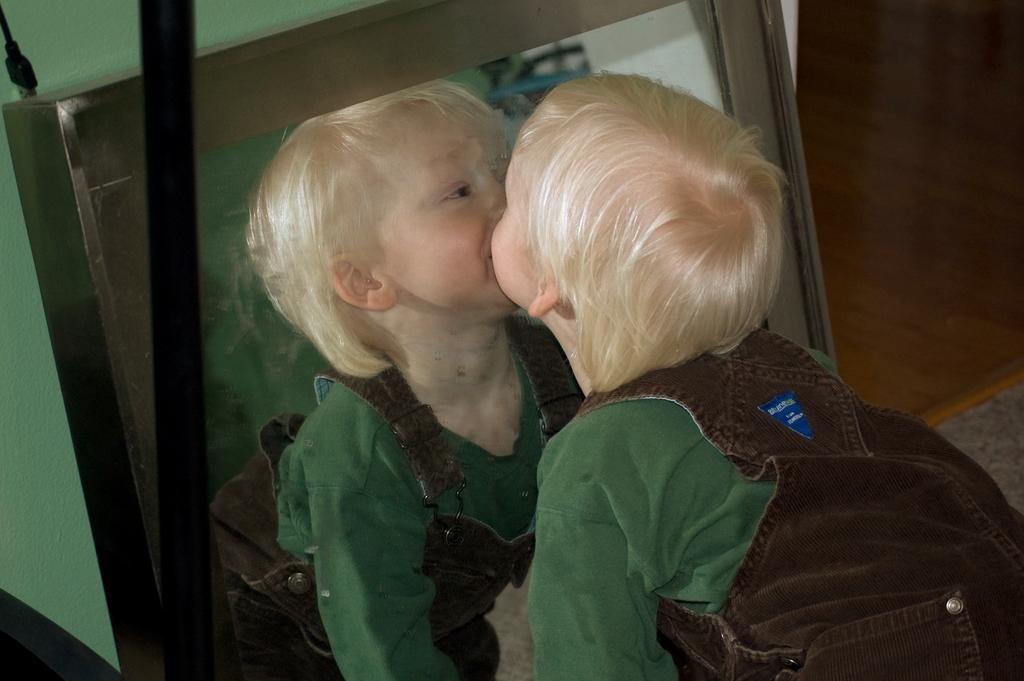Please provide a concise description of this image. In this image, on the right side, we can see a kid watching into the mirror. In the mirror, we can see mirror image of a kid. On the left side, we can see a black color pole. In the background, we can see a wall. 